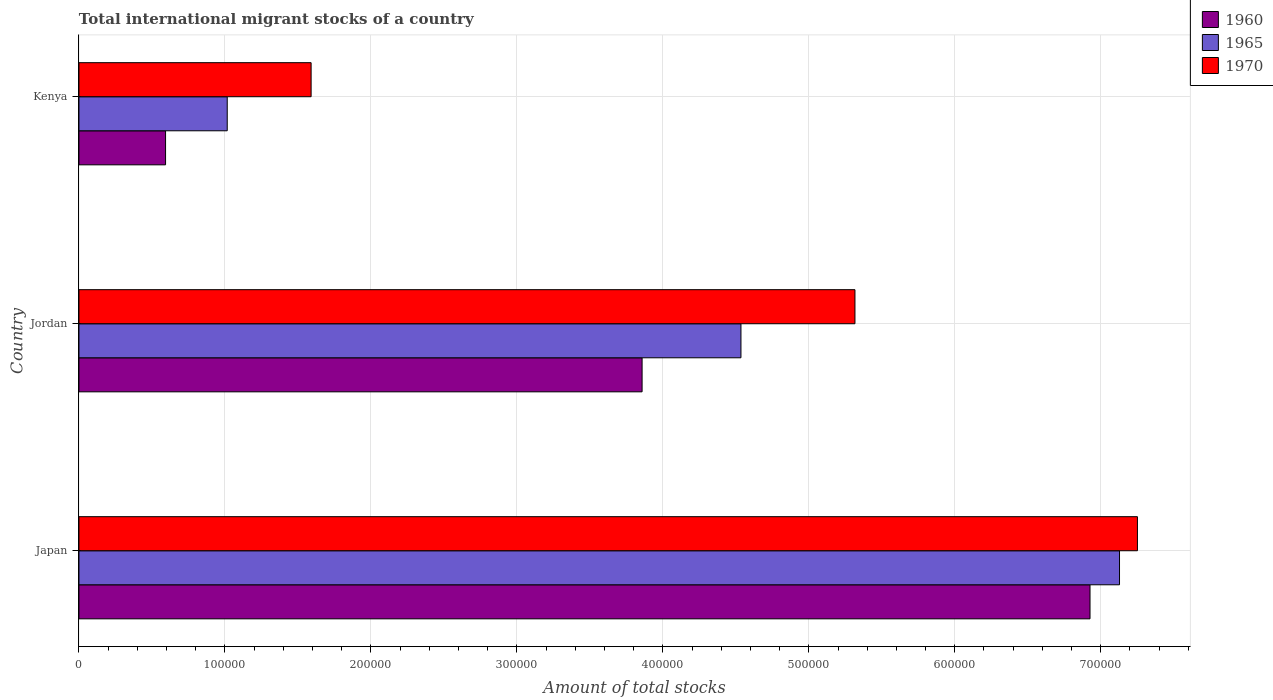How many groups of bars are there?
Offer a very short reply. 3. How many bars are there on the 3rd tick from the top?
Provide a short and direct response. 3. What is the label of the 1st group of bars from the top?
Ensure brevity in your answer.  Kenya. In how many cases, is the number of bars for a given country not equal to the number of legend labels?
Offer a very short reply. 0. What is the amount of total stocks in in 1970 in Kenya?
Offer a terse response. 1.59e+05. Across all countries, what is the maximum amount of total stocks in in 1960?
Offer a terse response. 6.93e+05. Across all countries, what is the minimum amount of total stocks in in 1965?
Ensure brevity in your answer.  1.02e+05. In which country was the amount of total stocks in in 1970 minimum?
Your answer should be compact. Kenya. What is the total amount of total stocks in in 1970 in the graph?
Keep it short and to the point. 1.42e+06. What is the difference between the amount of total stocks in in 1960 in Jordan and that in Kenya?
Provide a short and direct response. 3.26e+05. What is the difference between the amount of total stocks in in 1970 in Jordan and the amount of total stocks in in 1960 in Kenya?
Offer a very short reply. 4.72e+05. What is the average amount of total stocks in in 1960 per country?
Your response must be concise. 3.79e+05. What is the difference between the amount of total stocks in in 1965 and amount of total stocks in in 1960 in Jordan?
Your answer should be very brief. 6.77e+04. What is the ratio of the amount of total stocks in in 1970 in Jordan to that in Kenya?
Make the answer very short. 3.34. Is the amount of total stocks in in 1960 in Japan less than that in Jordan?
Provide a succinct answer. No. What is the difference between the highest and the second highest amount of total stocks in in 1965?
Make the answer very short. 2.59e+05. What is the difference between the highest and the lowest amount of total stocks in in 1965?
Keep it short and to the point. 6.11e+05. Is the sum of the amount of total stocks in in 1970 in Japan and Jordan greater than the maximum amount of total stocks in in 1965 across all countries?
Ensure brevity in your answer.  Yes. What does the 1st bar from the top in Kenya represents?
Give a very brief answer. 1970. What does the 2nd bar from the bottom in Kenya represents?
Offer a terse response. 1965. How many bars are there?
Provide a succinct answer. 9. Are all the bars in the graph horizontal?
Your answer should be compact. Yes. How many countries are there in the graph?
Your answer should be very brief. 3. What is the difference between two consecutive major ticks on the X-axis?
Make the answer very short. 1.00e+05. Are the values on the major ticks of X-axis written in scientific E-notation?
Provide a succinct answer. No. How are the legend labels stacked?
Ensure brevity in your answer.  Vertical. What is the title of the graph?
Give a very brief answer. Total international migrant stocks of a country. Does "1983" appear as one of the legend labels in the graph?
Offer a terse response. No. What is the label or title of the X-axis?
Provide a short and direct response. Amount of total stocks. What is the Amount of total stocks of 1960 in Japan?
Your answer should be very brief. 6.93e+05. What is the Amount of total stocks of 1965 in Japan?
Provide a short and direct response. 7.13e+05. What is the Amount of total stocks of 1970 in Japan?
Keep it short and to the point. 7.25e+05. What is the Amount of total stocks in 1960 in Jordan?
Your answer should be very brief. 3.86e+05. What is the Amount of total stocks in 1965 in Jordan?
Your response must be concise. 4.54e+05. What is the Amount of total stocks of 1970 in Jordan?
Your answer should be very brief. 5.32e+05. What is the Amount of total stocks of 1960 in Kenya?
Keep it short and to the point. 5.93e+04. What is the Amount of total stocks in 1965 in Kenya?
Your answer should be very brief. 1.02e+05. What is the Amount of total stocks of 1970 in Kenya?
Your response must be concise. 1.59e+05. Across all countries, what is the maximum Amount of total stocks of 1960?
Ensure brevity in your answer.  6.93e+05. Across all countries, what is the maximum Amount of total stocks in 1965?
Keep it short and to the point. 7.13e+05. Across all countries, what is the maximum Amount of total stocks in 1970?
Offer a very short reply. 7.25e+05. Across all countries, what is the minimum Amount of total stocks of 1960?
Ensure brevity in your answer.  5.93e+04. Across all countries, what is the minimum Amount of total stocks in 1965?
Your answer should be very brief. 1.02e+05. Across all countries, what is the minimum Amount of total stocks of 1970?
Make the answer very short. 1.59e+05. What is the total Amount of total stocks of 1960 in the graph?
Offer a terse response. 1.14e+06. What is the total Amount of total stocks in 1965 in the graph?
Provide a short and direct response. 1.27e+06. What is the total Amount of total stocks of 1970 in the graph?
Provide a short and direct response. 1.42e+06. What is the difference between the Amount of total stocks in 1960 in Japan and that in Jordan?
Your answer should be compact. 3.07e+05. What is the difference between the Amount of total stocks in 1965 in Japan and that in Jordan?
Your answer should be very brief. 2.59e+05. What is the difference between the Amount of total stocks in 1970 in Japan and that in Jordan?
Make the answer very short. 1.94e+05. What is the difference between the Amount of total stocks of 1960 in Japan and that in Kenya?
Offer a terse response. 6.33e+05. What is the difference between the Amount of total stocks of 1965 in Japan and that in Kenya?
Offer a very short reply. 6.11e+05. What is the difference between the Amount of total stocks of 1970 in Japan and that in Kenya?
Provide a succinct answer. 5.66e+05. What is the difference between the Amount of total stocks of 1960 in Jordan and that in Kenya?
Provide a succinct answer. 3.26e+05. What is the difference between the Amount of total stocks in 1965 in Jordan and that in Kenya?
Your response must be concise. 3.52e+05. What is the difference between the Amount of total stocks in 1970 in Jordan and that in Kenya?
Provide a succinct answer. 3.73e+05. What is the difference between the Amount of total stocks in 1960 in Japan and the Amount of total stocks in 1965 in Jordan?
Offer a very short reply. 2.39e+05. What is the difference between the Amount of total stocks of 1960 in Japan and the Amount of total stocks of 1970 in Jordan?
Provide a short and direct response. 1.61e+05. What is the difference between the Amount of total stocks in 1965 in Japan and the Amount of total stocks in 1970 in Jordan?
Keep it short and to the point. 1.81e+05. What is the difference between the Amount of total stocks of 1960 in Japan and the Amount of total stocks of 1965 in Kenya?
Offer a terse response. 5.91e+05. What is the difference between the Amount of total stocks of 1960 in Japan and the Amount of total stocks of 1970 in Kenya?
Make the answer very short. 5.34e+05. What is the difference between the Amount of total stocks of 1965 in Japan and the Amount of total stocks of 1970 in Kenya?
Your answer should be compact. 5.54e+05. What is the difference between the Amount of total stocks in 1960 in Jordan and the Amount of total stocks in 1965 in Kenya?
Provide a short and direct response. 2.84e+05. What is the difference between the Amount of total stocks in 1960 in Jordan and the Amount of total stocks in 1970 in Kenya?
Your answer should be compact. 2.27e+05. What is the difference between the Amount of total stocks of 1965 in Jordan and the Amount of total stocks of 1970 in Kenya?
Your answer should be compact. 2.94e+05. What is the average Amount of total stocks of 1960 per country?
Make the answer very short. 3.79e+05. What is the average Amount of total stocks of 1965 per country?
Keep it short and to the point. 4.23e+05. What is the average Amount of total stocks of 1970 per country?
Keep it short and to the point. 4.72e+05. What is the difference between the Amount of total stocks of 1960 and Amount of total stocks of 1965 in Japan?
Provide a short and direct response. -2.02e+04. What is the difference between the Amount of total stocks of 1960 and Amount of total stocks of 1970 in Japan?
Provide a succinct answer. -3.25e+04. What is the difference between the Amount of total stocks of 1965 and Amount of total stocks of 1970 in Japan?
Make the answer very short. -1.23e+04. What is the difference between the Amount of total stocks of 1960 and Amount of total stocks of 1965 in Jordan?
Ensure brevity in your answer.  -6.77e+04. What is the difference between the Amount of total stocks of 1960 and Amount of total stocks of 1970 in Jordan?
Keep it short and to the point. -1.46e+05. What is the difference between the Amount of total stocks of 1965 and Amount of total stocks of 1970 in Jordan?
Keep it short and to the point. -7.81e+04. What is the difference between the Amount of total stocks in 1960 and Amount of total stocks in 1965 in Kenya?
Provide a succinct answer. -4.23e+04. What is the difference between the Amount of total stocks of 1960 and Amount of total stocks of 1970 in Kenya?
Keep it short and to the point. -9.97e+04. What is the difference between the Amount of total stocks of 1965 and Amount of total stocks of 1970 in Kenya?
Keep it short and to the point. -5.75e+04. What is the ratio of the Amount of total stocks of 1960 in Japan to that in Jordan?
Provide a succinct answer. 1.8. What is the ratio of the Amount of total stocks of 1965 in Japan to that in Jordan?
Give a very brief answer. 1.57. What is the ratio of the Amount of total stocks of 1970 in Japan to that in Jordan?
Ensure brevity in your answer.  1.36. What is the ratio of the Amount of total stocks in 1960 in Japan to that in Kenya?
Your response must be concise. 11.67. What is the ratio of the Amount of total stocks in 1965 in Japan to that in Kenya?
Make the answer very short. 7.02. What is the ratio of the Amount of total stocks in 1970 in Japan to that in Kenya?
Ensure brevity in your answer.  4.56. What is the ratio of the Amount of total stocks in 1960 in Jordan to that in Kenya?
Provide a short and direct response. 6.5. What is the ratio of the Amount of total stocks of 1965 in Jordan to that in Kenya?
Provide a short and direct response. 4.46. What is the ratio of the Amount of total stocks in 1970 in Jordan to that in Kenya?
Provide a short and direct response. 3.34. What is the difference between the highest and the second highest Amount of total stocks in 1960?
Make the answer very short. 3.07e+05. What is the difference between the highest and the second highest Amount of total stocks in 1965?
Provide a short and direct response. 2.59e+05. What is the difference between the highest and the second highest Amount of total stocks of 1970?
Provide a short and direct response. 1.94e+05. What is the difference between the highest and the lowest Amount of total stocks of 1960?
Keep it short and to the point. 6.33e+05. What is the difference between the highest and the lowest Amount of total stocks of 1965?
Give a very brief answer. 6.11e+05. What is the difference between the highest and the lowest Amount of total stocks of 1970?
Give a very brief answer. 5.66e+05. 